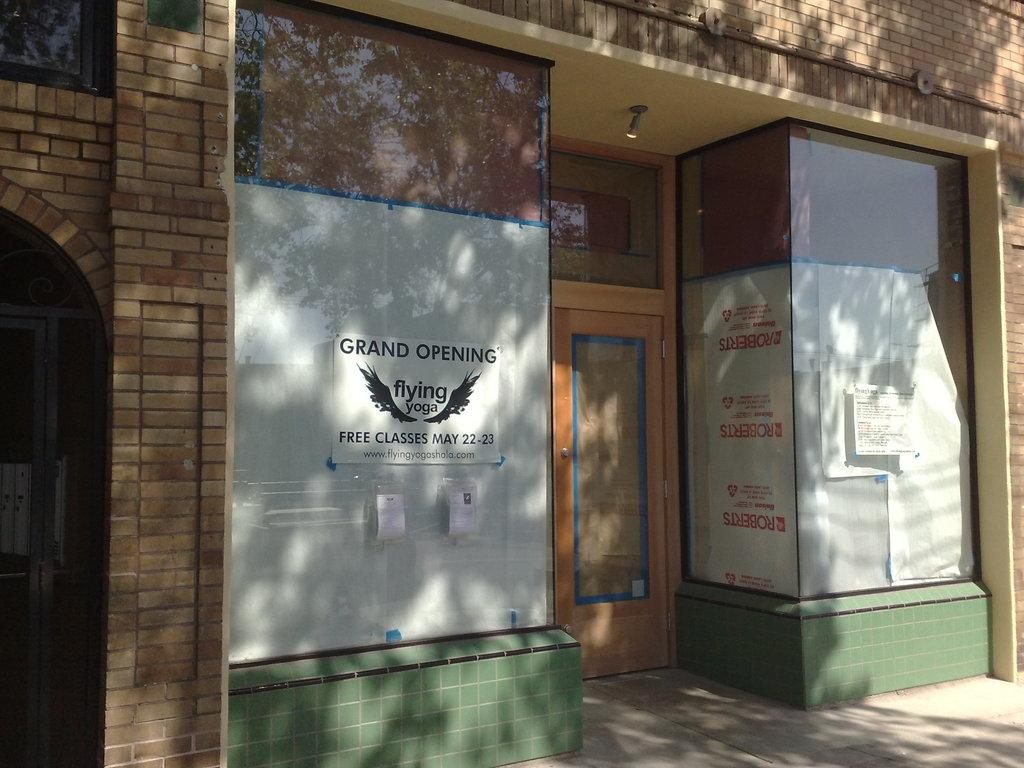What is on the boards in the image? There are papers on the boards in the image. What architectural feature is in the middle of the image? There is a door in the middle of the image. What is the source of light in the image? There is a light at the top of the image. What type of structure might the image depict? The image appears to depict a building. What color is the nail on the door in the image? There is no nail visible on the door in the image. Is the person wearing a sweater in the image? There are no people present in the image, so it is impossible to determine if anyone is wearing a sweater. Is there an umbrella visible in the image? There is no umbrella present in the image. 